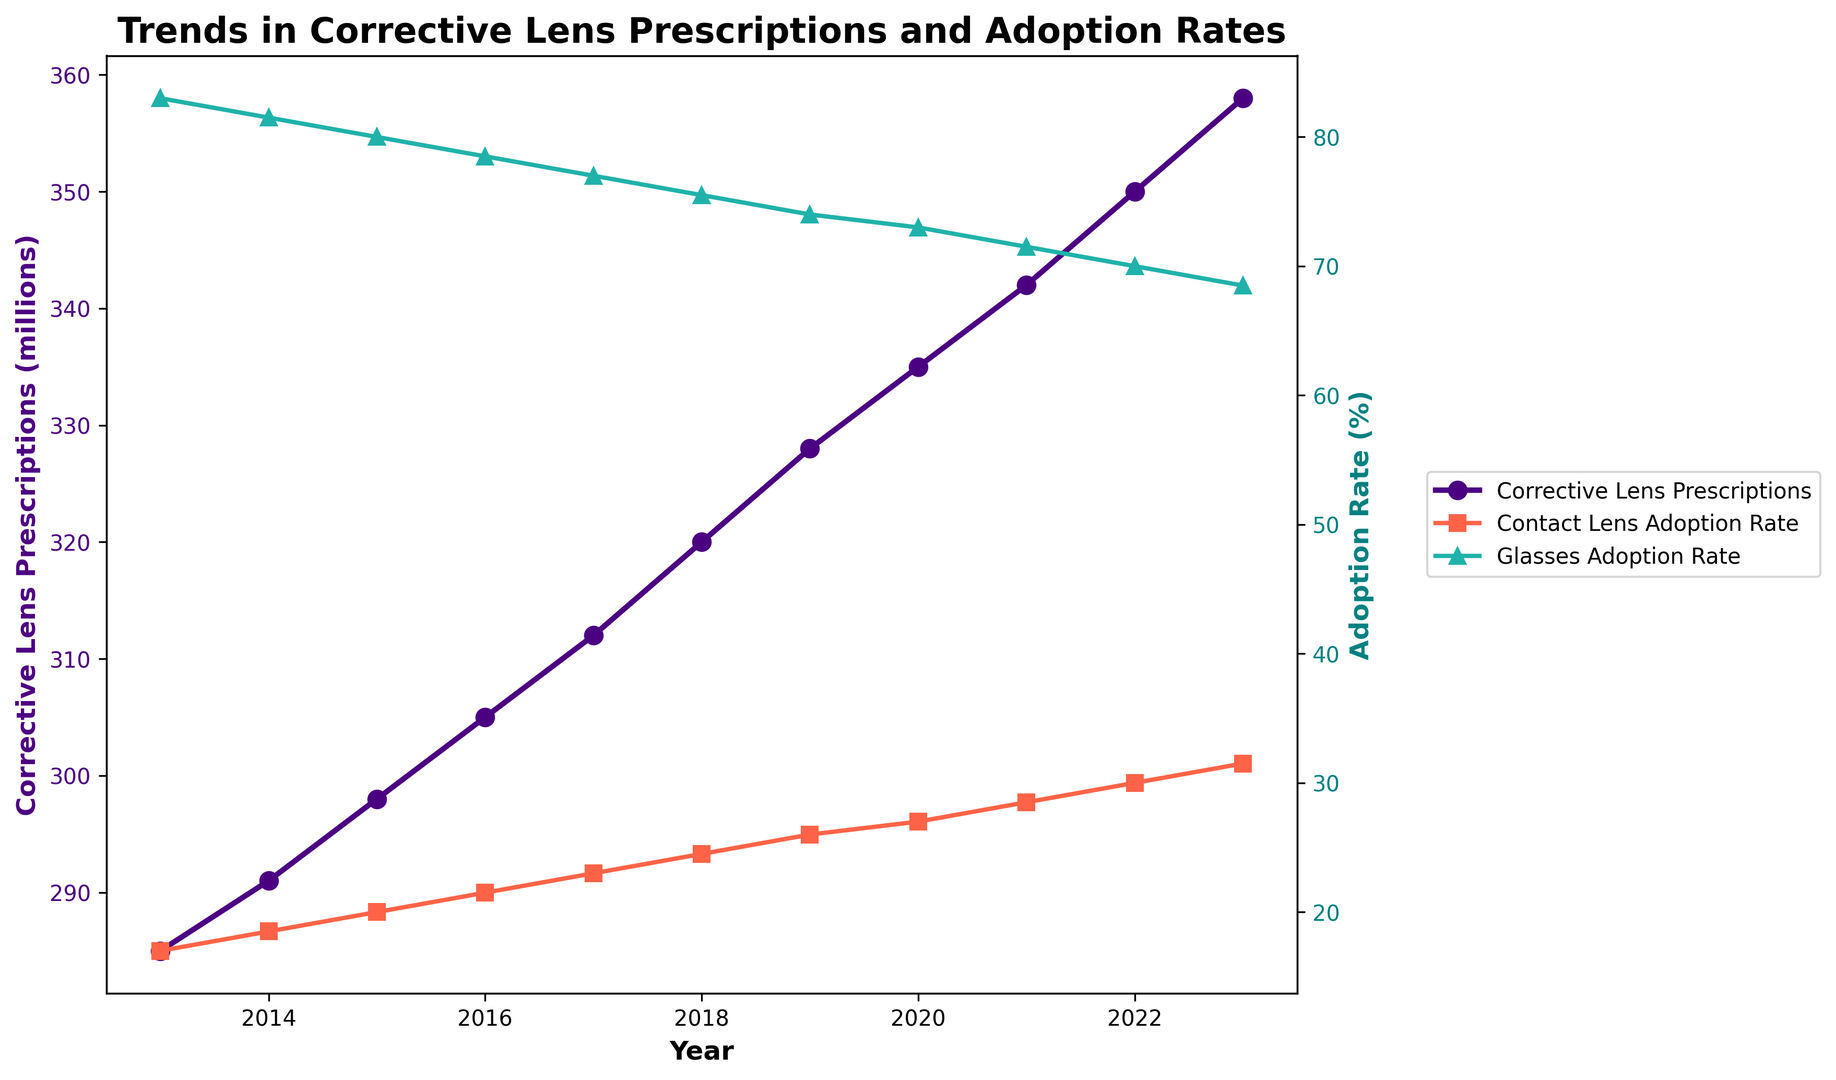What was the number of corrective lens prescriptions in 2023? Check the value on the y-axis for corrective lens prescriptions corresponding to the year 2023.
Answer: 358 million Which had a higher adoption rate in 2015, contact lenses or glasses? Compare the adoption rates of contact lenses and glasses for the year 2015. Glasses adoption rate was higher.
Answer: Glasses How has the adoption rate of contact lenses changed from 2015 to 2023? Subtract the adoption rate of contact lenses in 2015 from that in 2023. The change is 31.5% - 20% = 11.5%.
Answer: Increased by 11.5% In which year did the number of corrective lens prescriptions first exceed 300 million? Locate the year on the x-axis where the corrective lens prescriptions trend first crosses 300 million on the y-axis.
Answer: 2016 What is the difference between the glasses adoption rate in 2013 and 2023? Subtract the glasses adoption rate in 2023 from that in 2013. The difference is 83% - 68.5% = 14.5%.
Answer: 14.5% Which trend line shows the fastest increase over the years? Compare the slopes of the three trend lines (corrective lens prescriptions, contact lens adoption rate, glasses adoption rate). The contact lens adoption rate has the steepest slope.
Answer: Contact lens adoption rate By how much has the number of corrective lens prescriptions increased from 2013 to 2023? Subtract the number of corrective lens prescriptions in 2013 from that in 2023. The increase is 358 million - 285 million = 73 million.
Answer: 73 million What color represents the glasses adoption rate in the plot? Identify the color of the trend line and markers used for the glasses adoption rate.
Answer: Green What is the average contact lens adoption rate over the decade? Sum the contact lens adoption rates for each year and divide by the number of years (11). (17 + 18.5 + 20 + 21.5 + 23 + 24.5 + 26 + 27 + 28.5 + 30 + 31.5) / 11 = 24%
Answer: 24% How many years had an equal or more than 27% contact lens adoption rate? Identify the years where the contact lens adoption rate was 27% or higher by checking the relevant trend line. The years are 2020, 2021, 2022, and 2023, totaling 4 years.
Answer: 4 years 